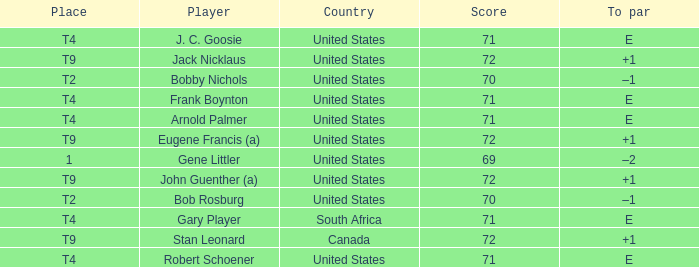What is To Par, when Country is "United States", when Place is "T4", and when Player is "Frank Boynton"? E. 